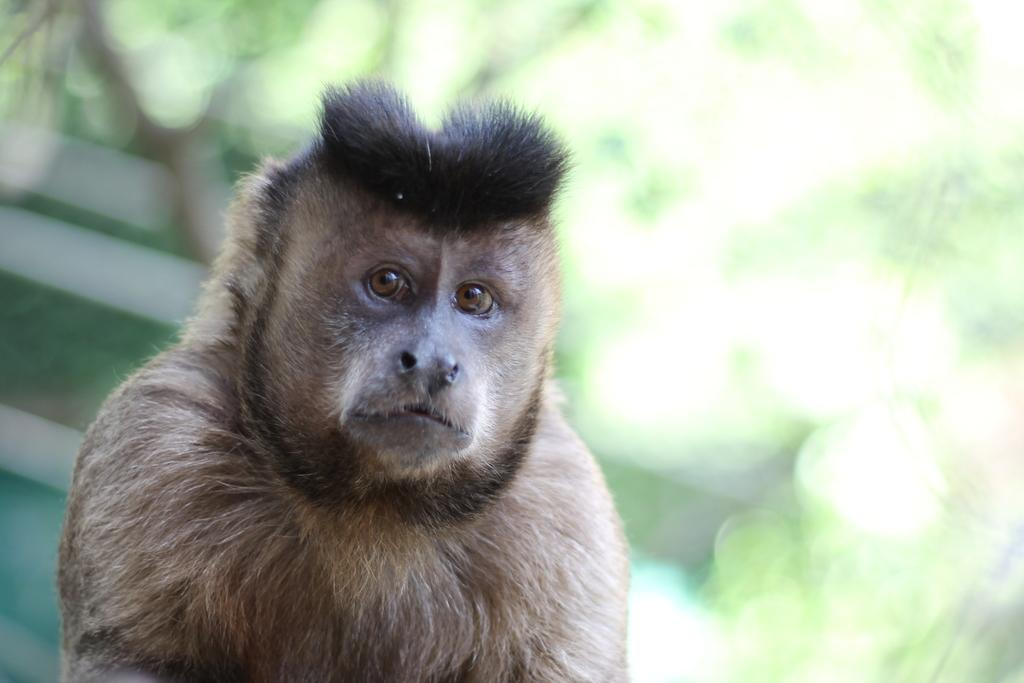What type of living creature can be seen in the image? There is an animal in the image. What type of current is flowing through the animal in the image? There is no current present in the image, as it features an animal without any indication of electricity or water flow. 